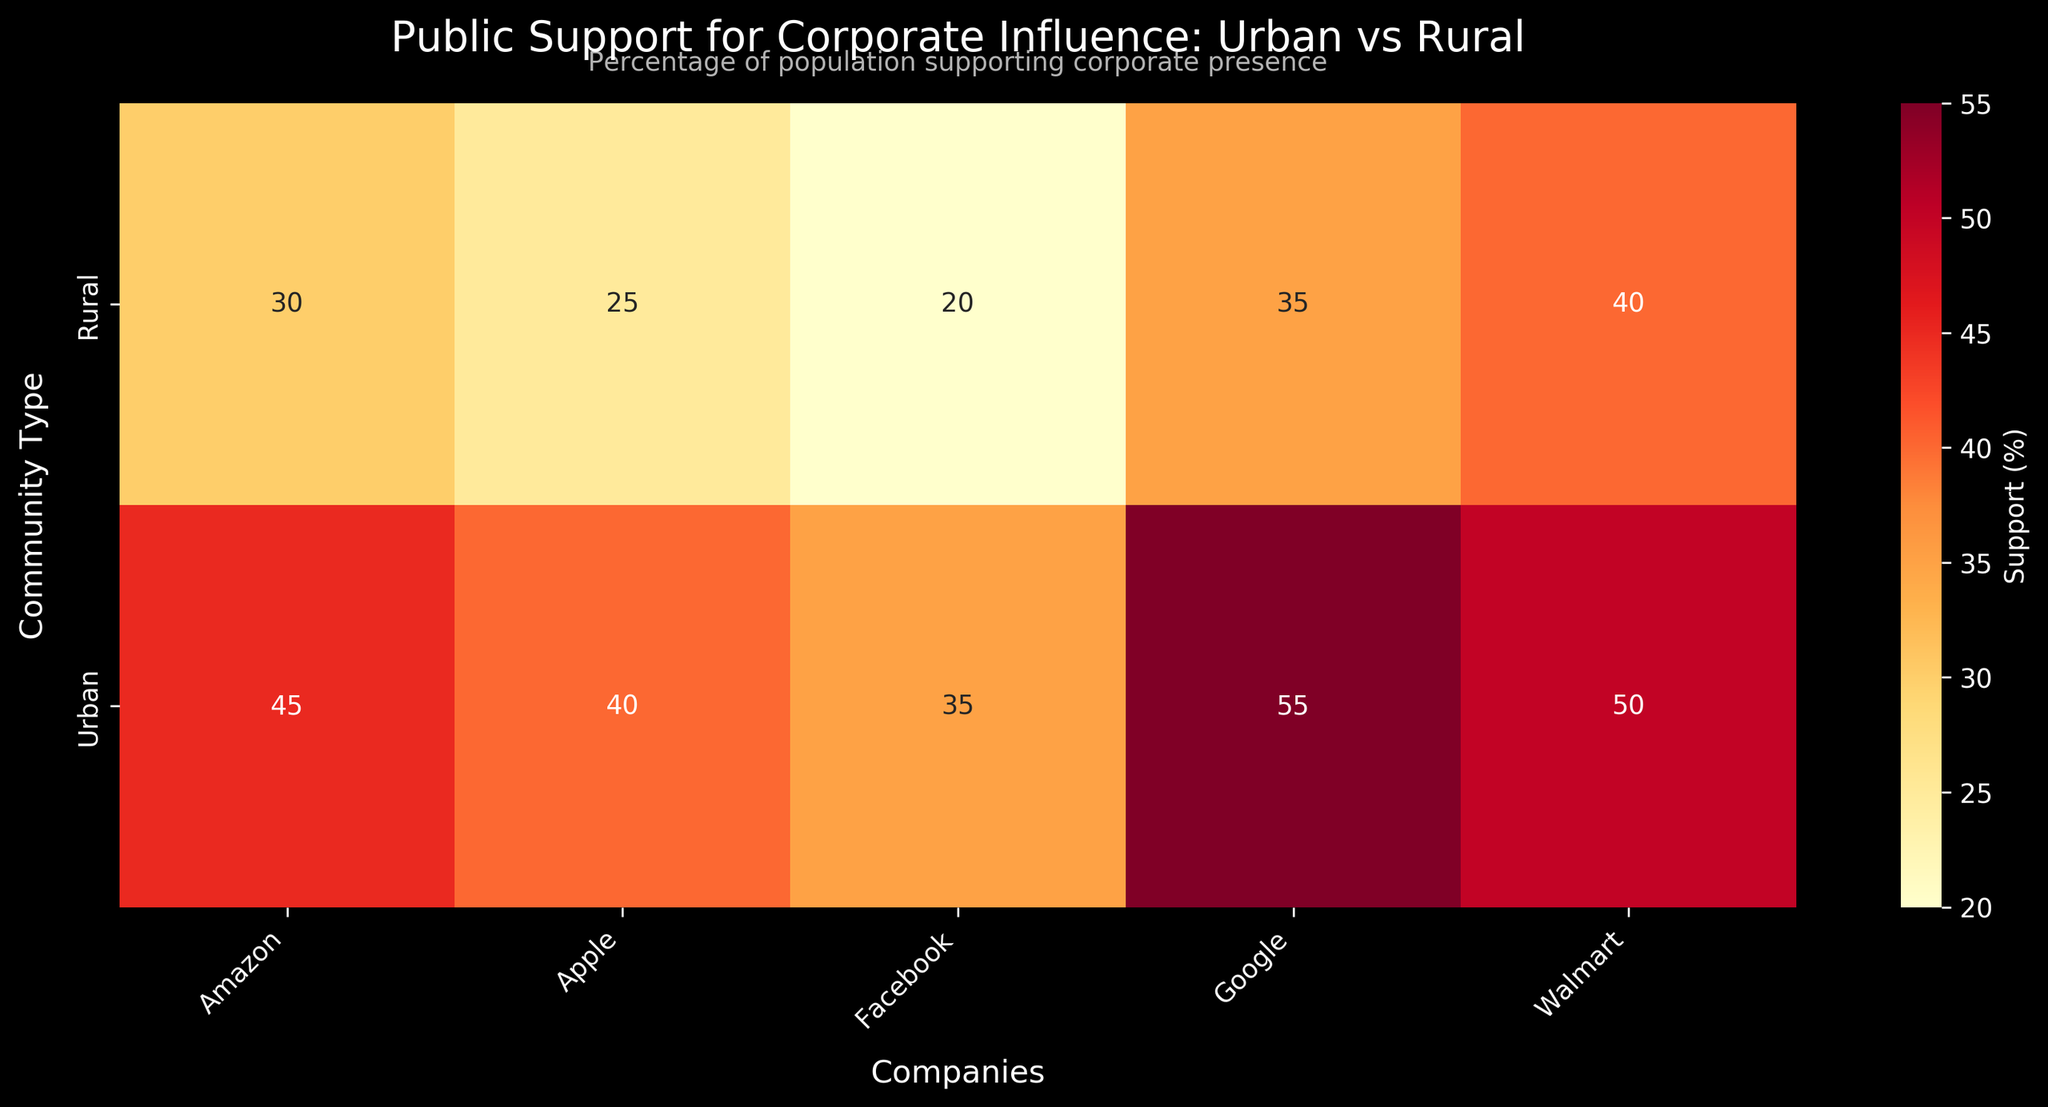What is the title of the heatmap? The title of the heatmap is displayed at the top, and it reads "Public Support for Corporate Influence: Urban vs Rural".
Answer: Public Support for Corporate Influence: Urban vs Rural Which company has the highest percentage of support in urban communities? By looking at the heatmap values for urban communities, the company with the highest percentage of support is Google, with 55%.
Answer: Google How does support for Amazon compare between urban and rural communities? In urban communities, Amazon has 45% support. In rural communities, it has 30% support. Thus, support for Amazon is higher in urban communities by 15%.
Answer: Higher in urban by 15% Which company has the least support in rural communities? By examining the heatmap values for rural communities, the company with the least support is Facebook, with 20%.
Answer: Facebook What is the average support percentage for companies in rural communities? The support percentages for rural communities are: Amazon 30%, Apple 25%, Walmart 40%, Google 35%, and Facebook 20%. Summing these values gives 150, and dividing by 5 gives an average of 30%.
Answer: 30% Which community type shows more variation in support percentages among different companies? Urban community support percentages are: Amazon 45%, Apple 40%, Walmart 50%, Google 55%, Facebook 35%. For rural: Amazon 30%, Apple 25%, Walmart 40%, Google 35%, Facebook 20%. Urban ranges from 35% to 55% (20% spread), while Rural ranges from 20% to 40% (20% spread). Both have similar variation spreads of 20%, so neither shows more variation.
Answer: Neither Which company has the closest support percentage between urban and rural communities? Calculating differences: Amazon: 15% (45-30), Apple: 15% (40-25), Walmart: 10% (50-40), Google: 20% (55-35), Facebook: 15% (35-20). Walmart has the least difference with 10%.
Answer: Walmart How much more support does Google have compared to Apple in rural communities? In rural communities, Google has 35% support whereas Apple has 25%. The difference is 35% - 25% = 10%.
Answer: 10% Why could public sentiment towards Facebook be so different between urban and rural communities? The heatmap shows Facebook has high opposition and low support in rural areas compared to urban areas. The difference may stem from various factors like more negative perception of digital privacy issues, or influence of local culture and less digital engagement in rural areas.
Answer: Varies by community influences List all companies with higher than 25% support in rural communities. The companies with support values higher than 25% in rural communities are Amazon (30%), Walmart (40%), and Google (35%).
Answer: Amazon, Walmart, Google 